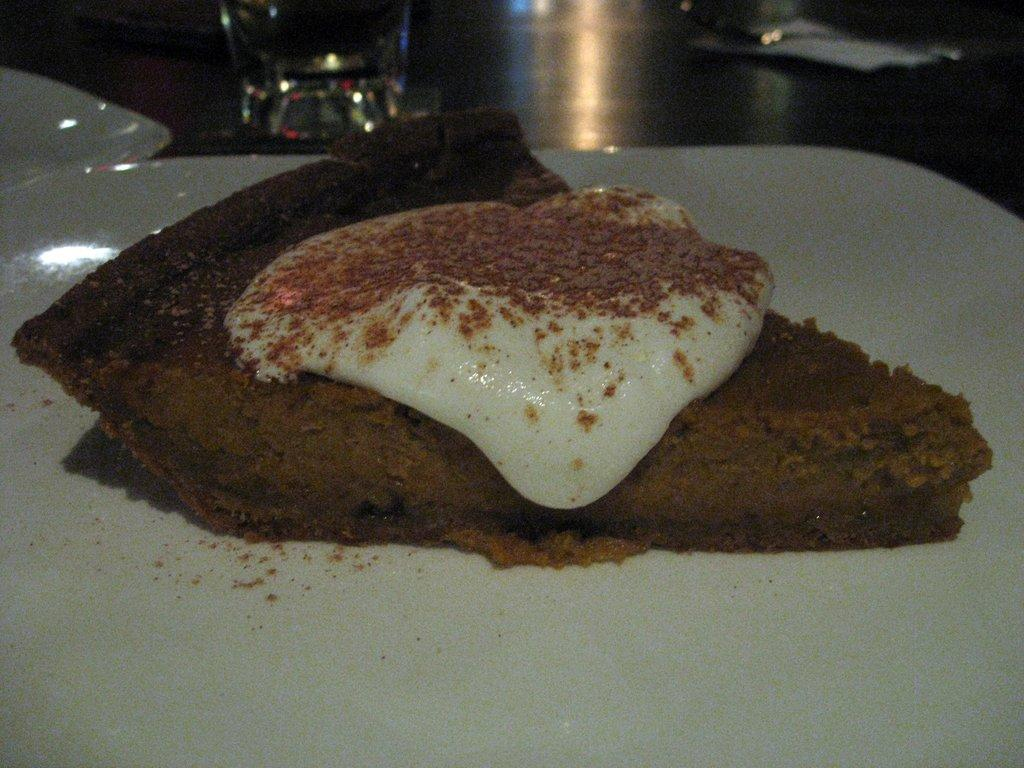What is on the plate that is visible in the image? There is a food item on a plate in the image. How many plates can be seen in the image? There is another plate in the image, making a total of two plates. What is the glass used for in the image? The glass is likely used for holding a beverage. What other objects are present on the platform in the image? There are other objects on the platform in the image, but their specific details are not mentioned in the provided facts. What type of jam is visible on the plate in the image? There is no jam visible on the plate in the image; only a food item is mentioned. 